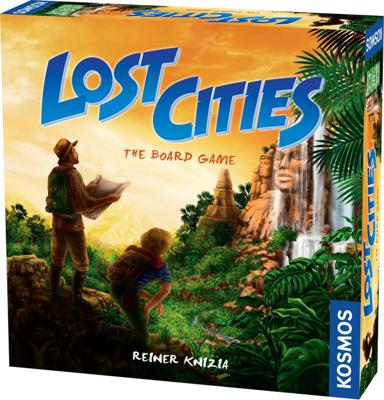Who is the designer of the game? The creative mind behind 'Lost Cities' is Reiner Knizia, a prolific board game designer known for designing games that blend simple mechanics with deep strategic play. 